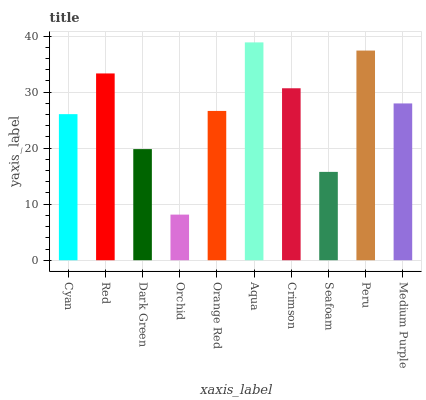Is Orchid the minimum?
Answer yes or no. Yes. Is Aqua the maximum?
Answer yes or no. Yes. Is Red the minimum?
Answer yes or no. No. Is Red the maximum?
Answer yes or no. No. Is Red greater than Cyan?
Answer yes or no. Yes. Is Cyan less than Red?
Answer yes or no. Yes. Is Cyan greater than Red?
Answer yes or no. No. Is Red less than Cyan?
Answer yes or no. No. Is Medium Purple the high median?
Answer yes or no. Yes. Is Orange Red the low median?
Answer yes or no. Yes. Is Dark Green the high median?
Answer yes or no. No. Is Peru the low median?
Answer yes or no. No. 